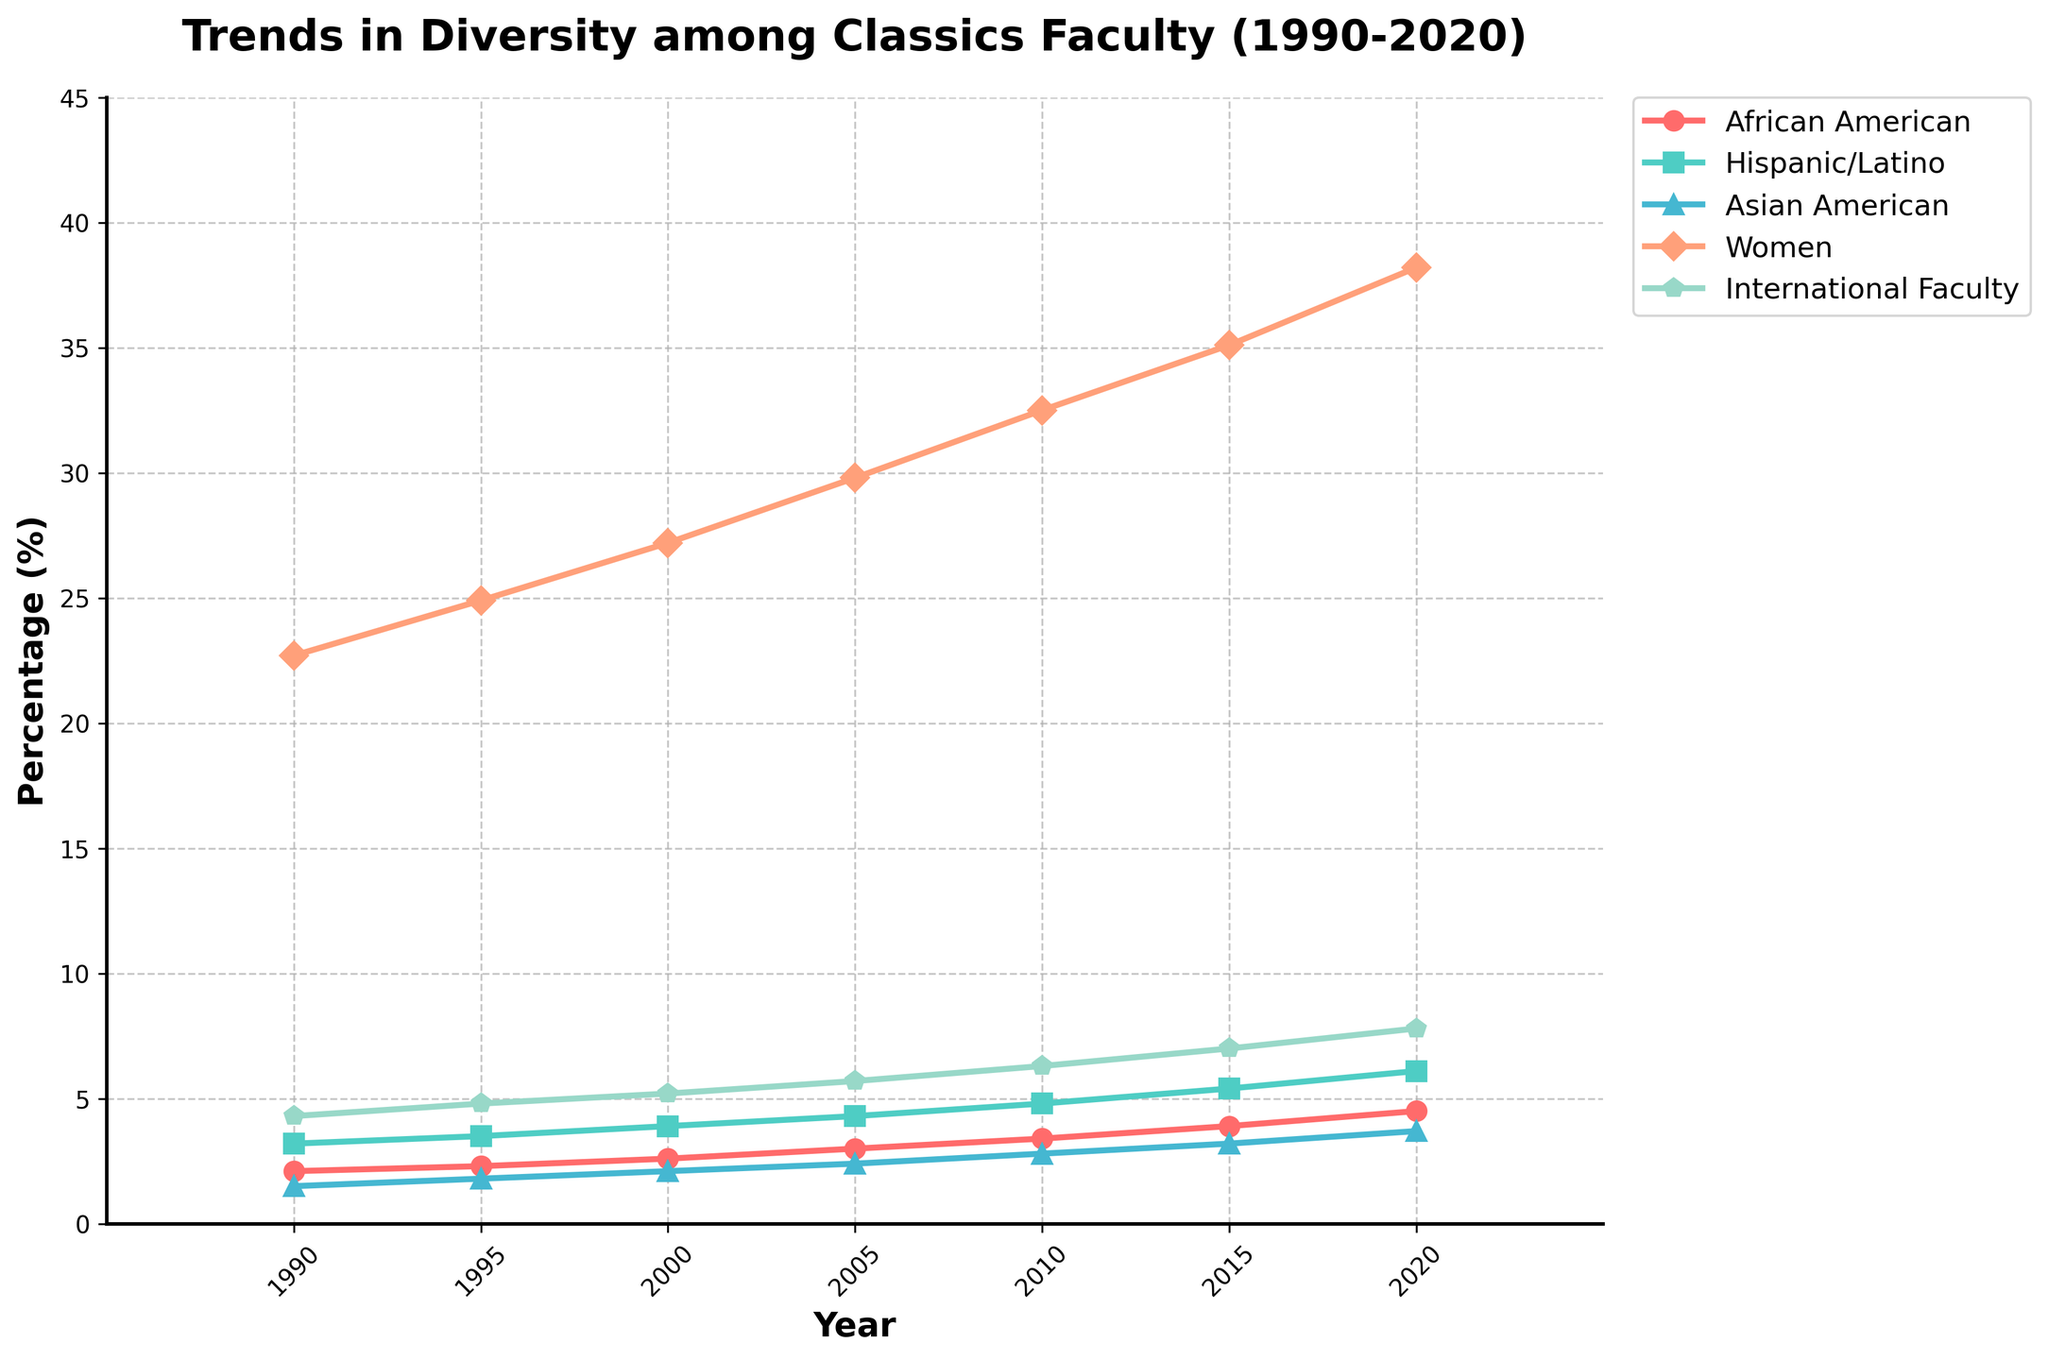What's the trend in the percentage of Women faculty from 1990 to 2020? From the chart, observe the line corresponding to Women faculty. It starts at 22.7% in 1990, increases steadily over time, and reaches 38.2% in 2020, indicating a positive upward trend.
Answer: Increasing Which group saw the largest increase in percentage over the 30-year period? By comparing the starting and ending percentages of each group, Women faculty increased from 22.7% to 38.2%, a difference of 15.5%, which is the largest increase among all groups.
Answer: Women What is the cumulative percentage of African American, Hispanic/Latino, and Asian American faculty in 2020? From the chart, the percentages in 2020 are African American (4.5%), Hispanic/Latino (6.1%), and Asian American (3.7%). Summing these up: 4.5% + 6.1% + 3.7% = 14.3%.
Answer: 14.3% Between African American and Asian American faculty, which group had a higher percentage in 2000? Looking at the chart for the year 2000, African American faculty had 2.6% while Asian American faculty had 2.1%. Therefore, African American faculty had a higher percentage.
Answer: African American Did the percentage of International Faculty exceed 7% before 2020? Observing the line for International Faculty, it reaches 7% in 2015 and increases to 7.8% in 2020. Hence, it did not exceed 7% before 2020.
Answer: No What's the combined total increase in percentage for African American and Hispanic/Latino faculty from 1990 to 2020? From the chart, African American faculty increased from 2.1% to 4.5% (+2.4%), and Hispanic/Latino faculty from 3.2% to 6.1% (+2.9%). The total increase is 2.4% + 2.9% = 5.3%.
Answer: 5.3% In which year did the percentage of Hispanic/Latino faculty first surpass 4%? Observing the line for Hispanic/Latino faculty, it surpasses 4% in 2005 where it reached 4.3%.
Answer: 2005 Which group had the least percentage change from 1990 to 2020? Comparing the start and end percentages for each group, African American went from 2.1% to 4.5% (+2.4%), Hispanic/Latino from 3.2% to 6.1% (+2.9%), Asian American from 1.5% to 3.7% (+2.2%), Women from 22.7% to 38.2% (+15.5%), International Faculty from 4.3% to 7.8% (+3.5%). Hence, Asian American had the least percentage change.
Answer: Asian American What's the average percentage of Women faculty over the entire period? Sum the percentages for Women faculty from 1990 to 2020: (22.7 + 24.9 + 27.2 + 29.8 + 32.5 + 35.1 + 38.2) = 210.4. Divide by 7 (the number of data points), giving 210.4 / 7 ≈ 30.1%.
Answer: 30.1% 